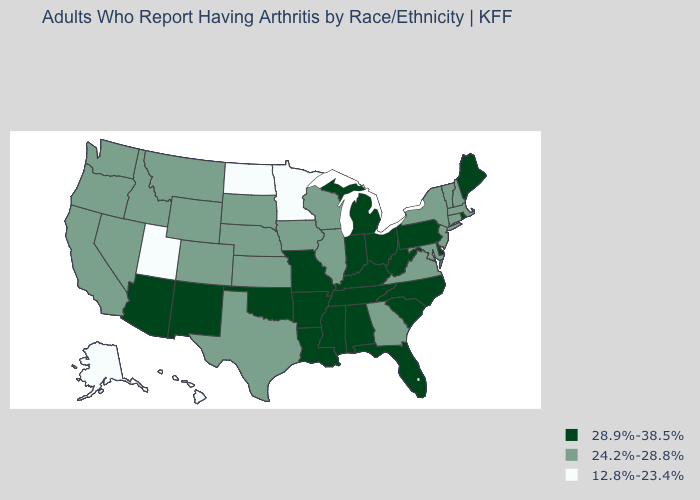Is the legend a continuous bar?
Answer briefly. No. Name the states that have a value in the range 12.8%-23.4%?
Be succinct. Alaska, Hawaii, Minnesota, North Dakota, Utah. Name the states that have a value in the range 12.8%-23.4%?
Be succinct. Alaska, Hawaii, Minnesota, North Dakota, Utah. What is the highest value in the South ?
Give a very brief answer. 28.9%-38.5%. What is the highest value in the USA?
Short answer required. 28.9%-38.5%. What is the highest value in the USA?
Keep it brief. 28.9%-38.5%. What is the value of South Dakota?
Answer briefly. 24.2%-28.8%. Does the map have missing data?
Keep it brief. No. Does North Dakota have the highest value in the MidWest?
Quick response, please. No. Among the states that border Louisiana , which have the highest value?
Answer briefly. Arkansas, Mississippi. What is the value of Louisiana?
Be succinct. 28.9%-38.5%. Name the states that have a value in the range 28.9%-38.5%?
Keep it brief. Alabama, Arizona, Arkansas, Delaware, Florida, Indiana, Kentucky, Louisiana, Maine, Michigan, Mississippi, Missouri, New Mexico, North Carolina, Ohio, Oklahoma, Pennsylvania, Rhode Island, South Carolina, Tennessee, West Virginia. Does Vermont have the highest value in the Northeast?
Be succinct. No. What is the value of Nevada?
Concise answer only. 24.2%-28.8%. Does Texas have the lowest value in the South?
Quick response, please. Yes. 